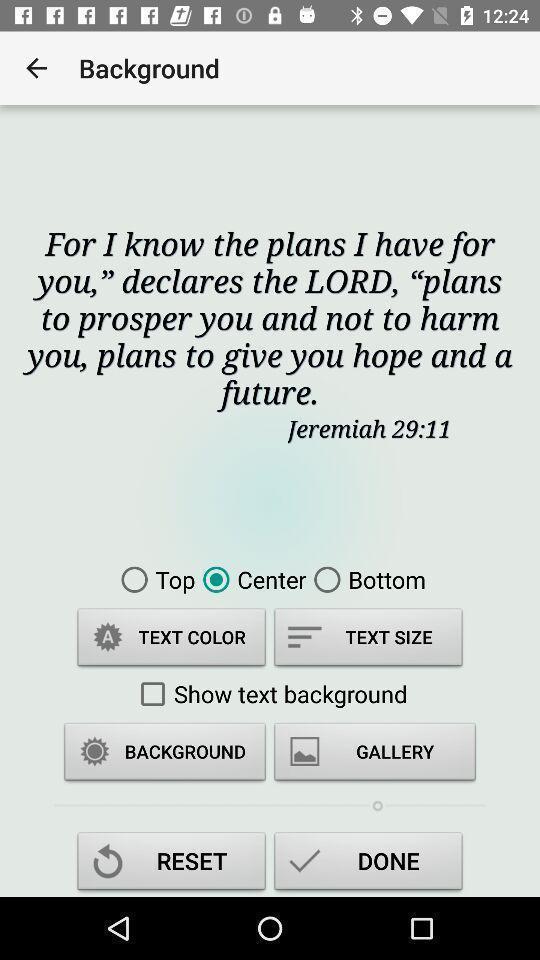Describe this image in words. Setting page of background for a bible app. 